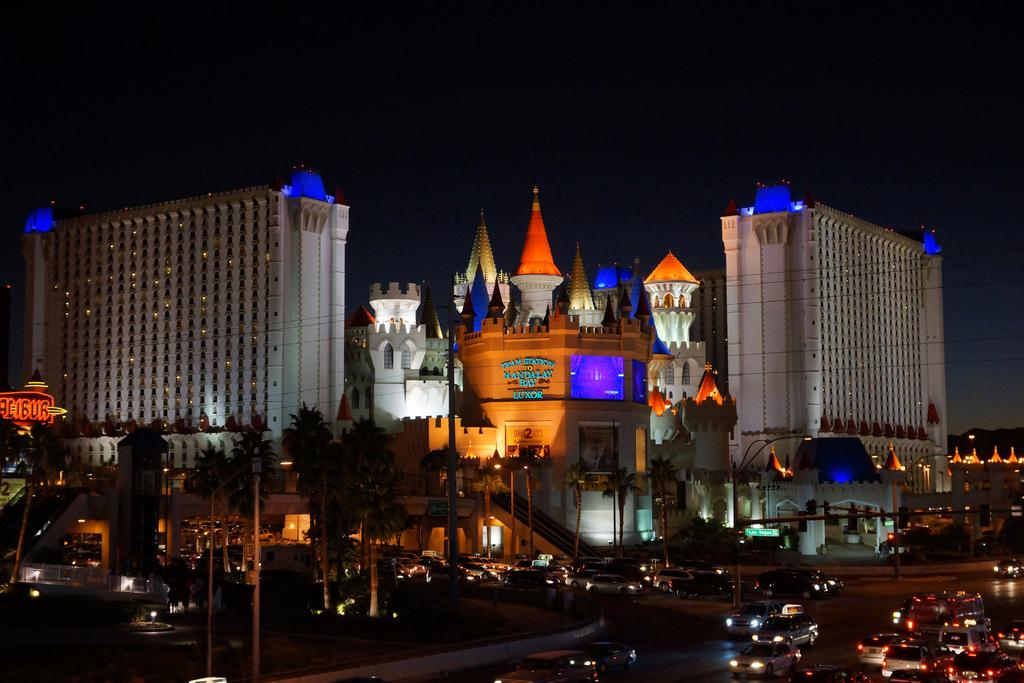What can be seen on the road in the image? There are many vehicles on the road in the image. What type of natural elements are visible in the image? There are trees visible in the image. What type of man-made structures can be seen in the image? There are buildings in the image. What is visible in the background of the image? The sky is visible in the background of the image. What type of illumination is present in the image? There are lights in the image. What type of skirt is being worn by the stone beggar in the image? There is no skirt, stone, or beggar present in the image. 